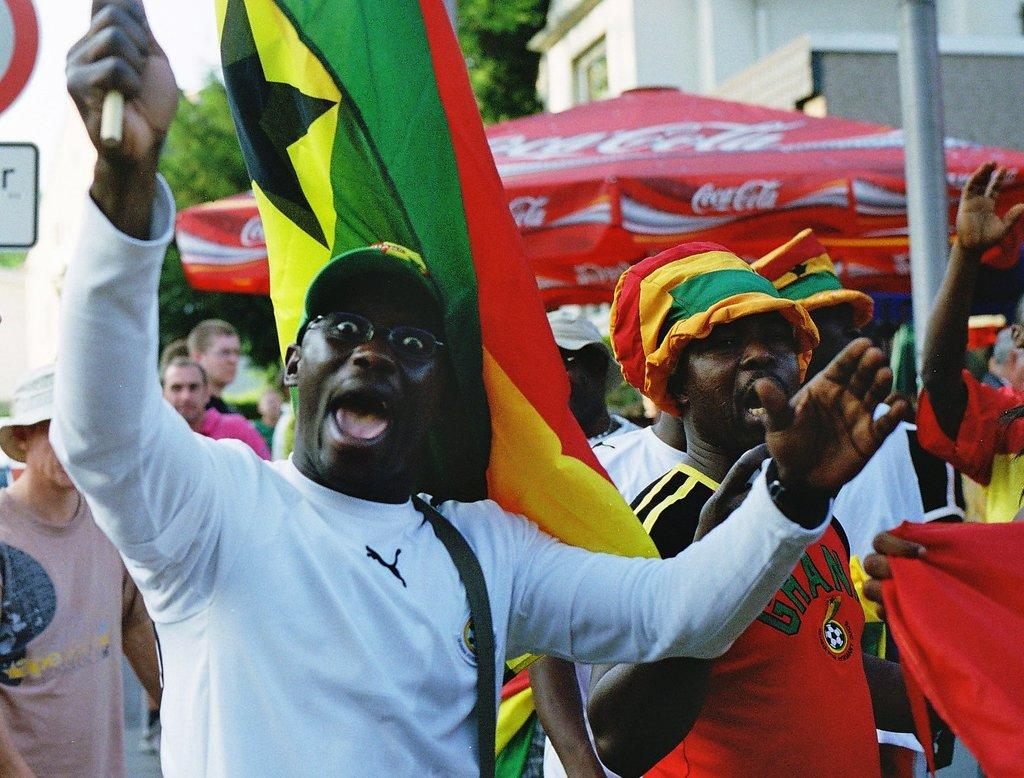What is the person in the image wearing? The person is wearing a white T-shirt in the image. What is the person holding in their hands? The person is holding a stick in their hands. How many other persons are visible in the image? There are other persons in the image. What object can be seen in the image for protection from the sun or rain? There is an umbrella in the image. What can be seen in the background of the image? There is a building and trees in the background of the image. How many fingers can be seen on the person's hand holding the stick in the image? The image does not show the person's fingers holding the stick, so it is not possible to determine the number of fingers. 